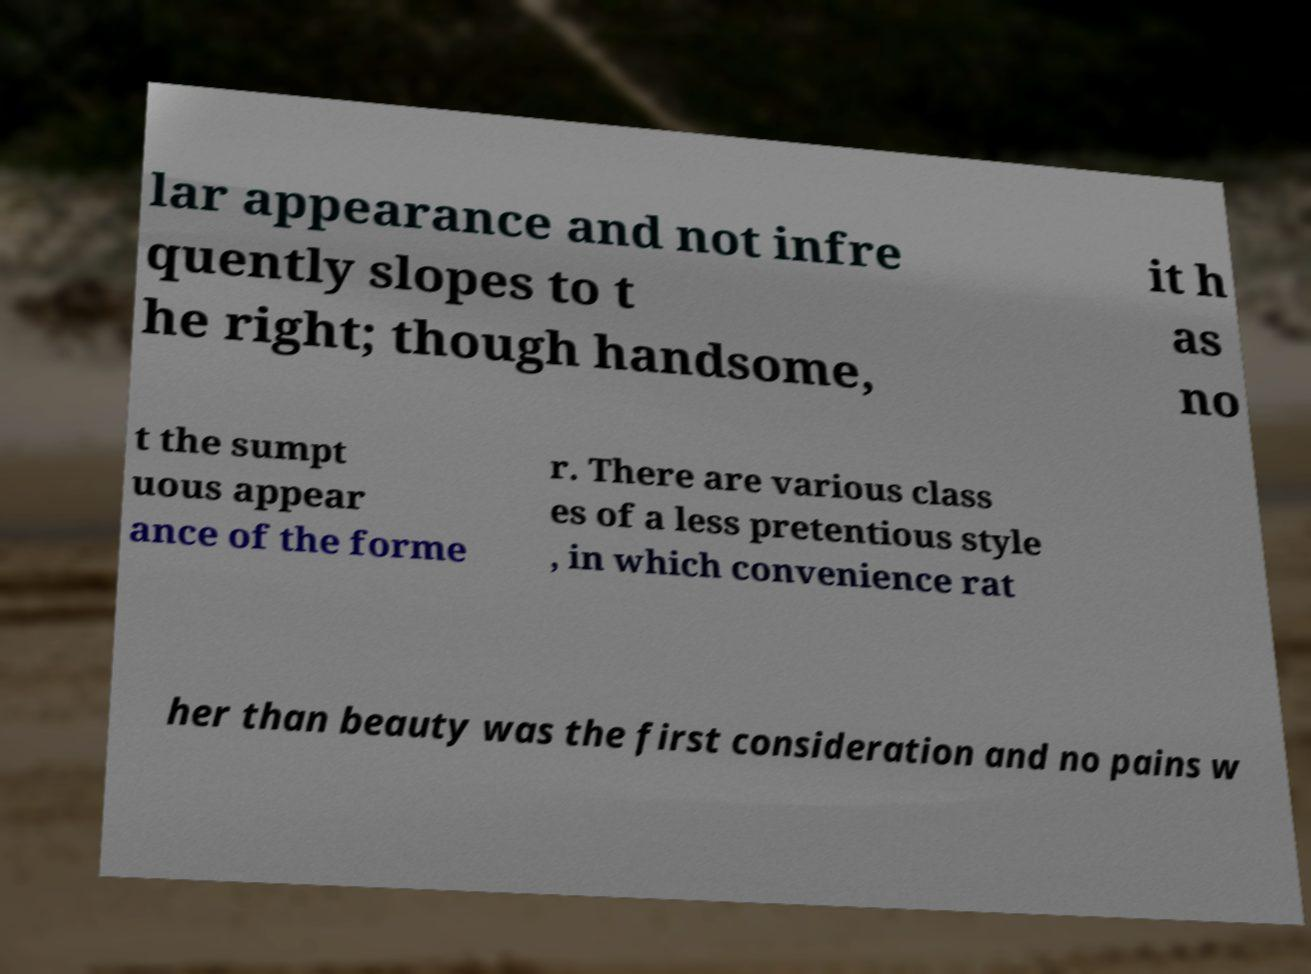What messages or text are displayed in this image? I need them in a readable, typed format. lar appearance and not infre quently slopes to t he right; though handsome, it h as no t the sumpt uous appear ance of the forme r. There are various class es of a less pretentious style , in which convenience rat her than beauty was the first consideration and no pains w 